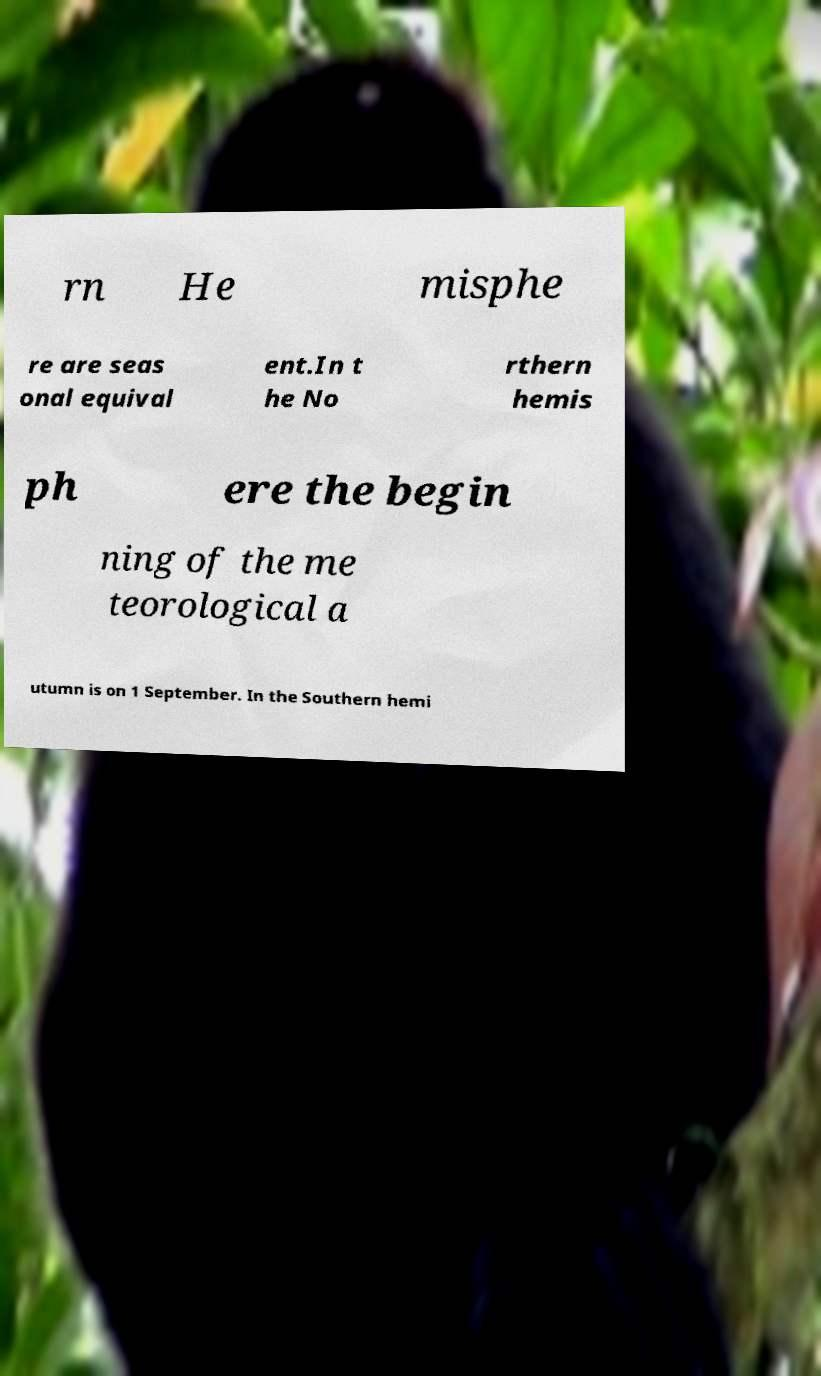Can you accurately transcribe the text from the provided image for me? rn He misphe re are seas onal equival ent.In t he No rthern hemis ph ere the begin ning of the me teorological a utumn is on 1 September. In the Southern hemi 